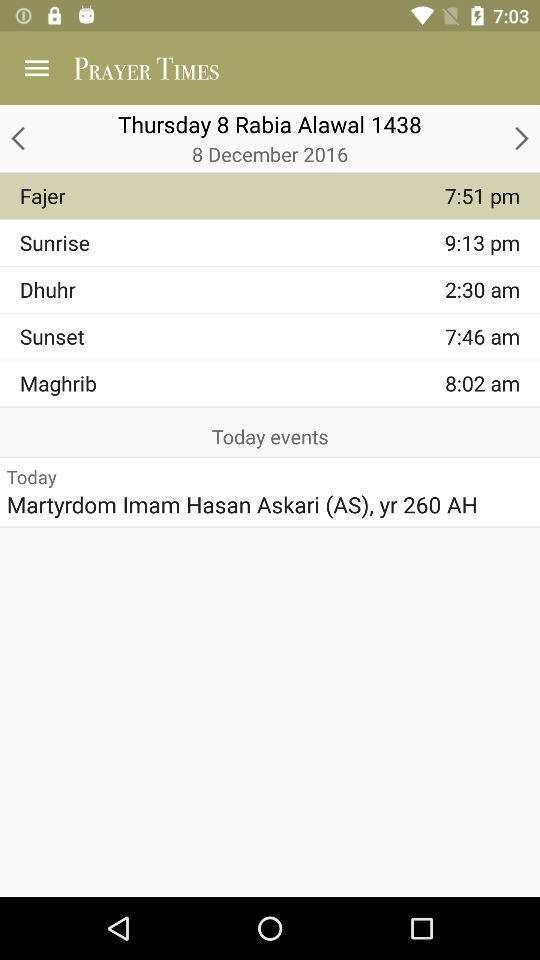Which prayer is at 12:23 PM?
When the provided information is insufficient, respond with <no answer>. <no answer> 